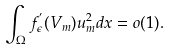Convert formula to latex. <formula><loc_0><loc_0><loc_500><loc_500>\int _ { \Omega } f _ { \epsilon } ^ { ^ { \prime } } ( V _ { m } ) u _ { m } ^ { 2 } d x = o ( 1 ) .</formula> 